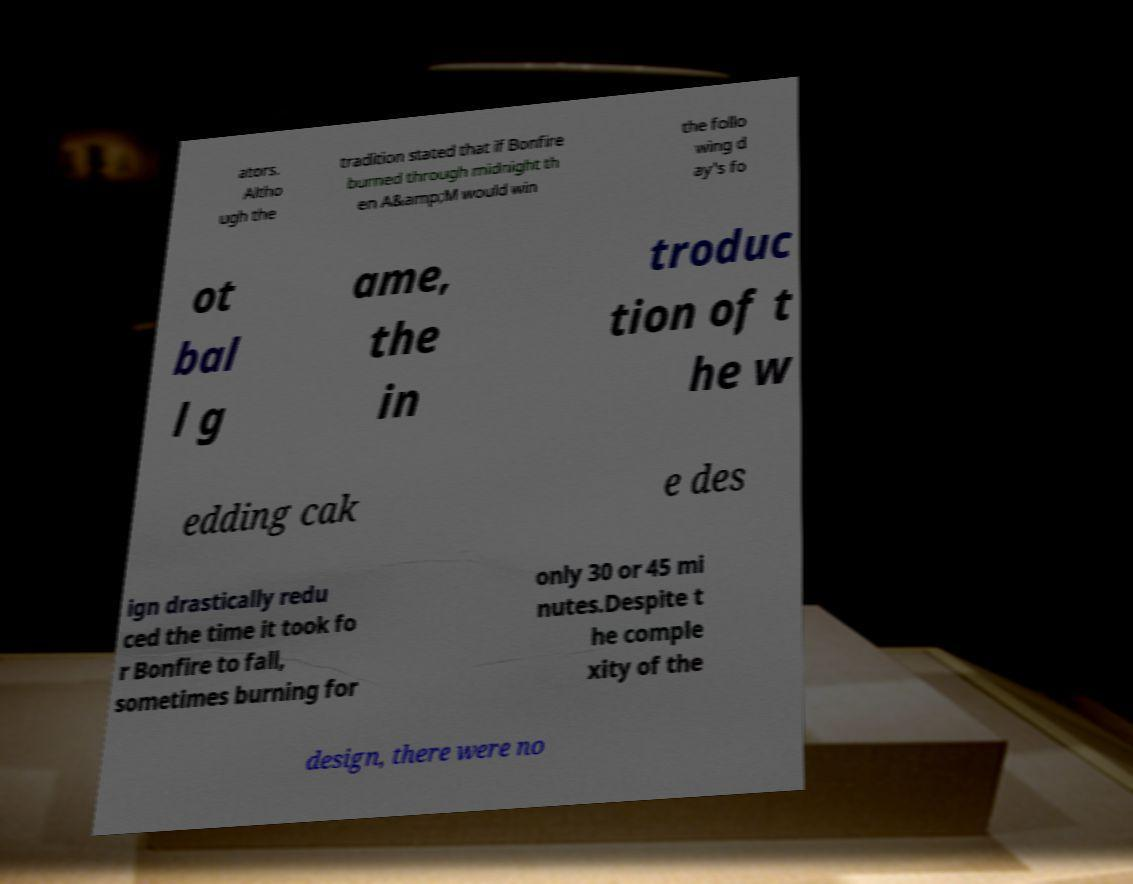Please identify and transcribe the text found in this image. ators. Altho ugh the tradition stated that if Bonfire burned through midnight th en A&amp;M would win the follo wing d ay's fo ot bal l g ame, the in troduc tion of t he w edding cak e des ign drastically redu ced the time it took fo r Bonfire to fall, sometimes burning for only 30 or 45 mi nutes.Despite t he comple xity of the design, there were no 